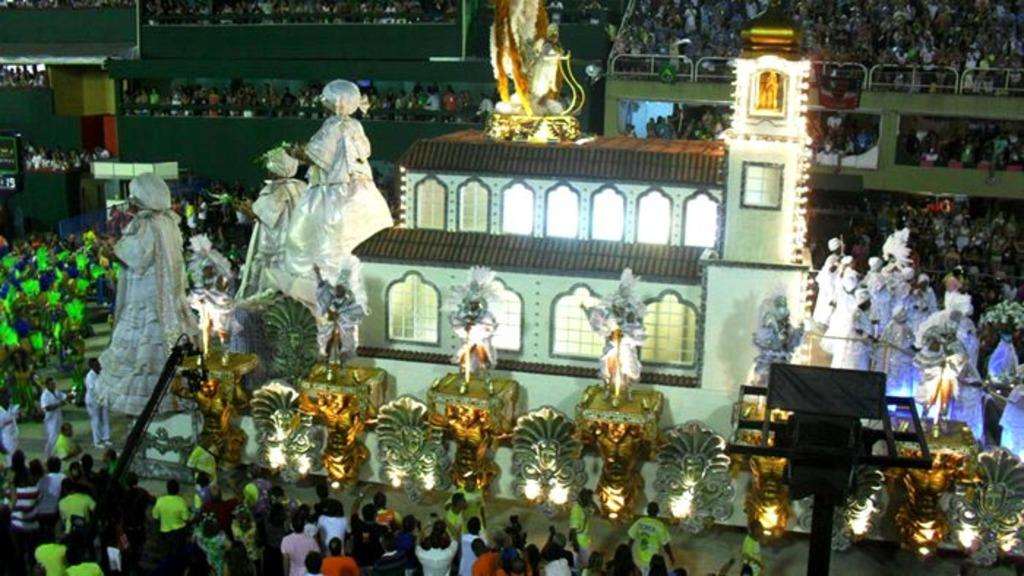What type of artwork can be seen in the image? There are sculptures in the image. Are there any people present in the image? Yes, there are people standing in the image. What can be found in the middle of the image? There are lights in the middle of the image. What degrees do the children in the image have? There are no children present in the image, and therefore no degrees can be attributed to them. 